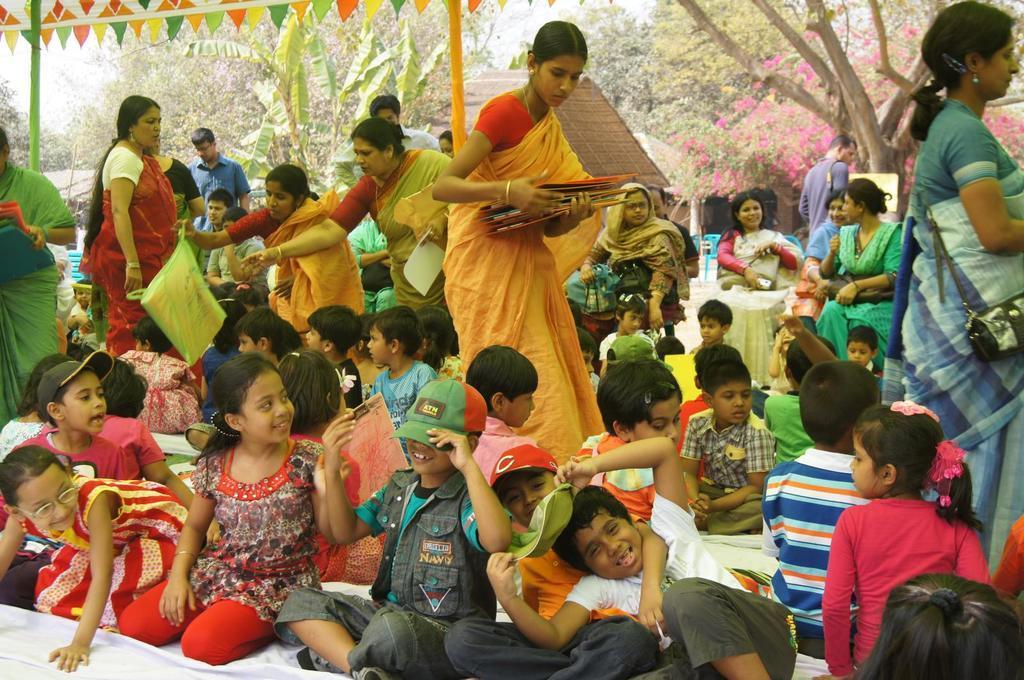Can you describe this image briefly? In this image I can see number of children are sitting on the ground, few persons are sitting on chairs, few persons standing and holding few objects in their hands. In the background I can see few trees, few flowers, few poles and the sky. 